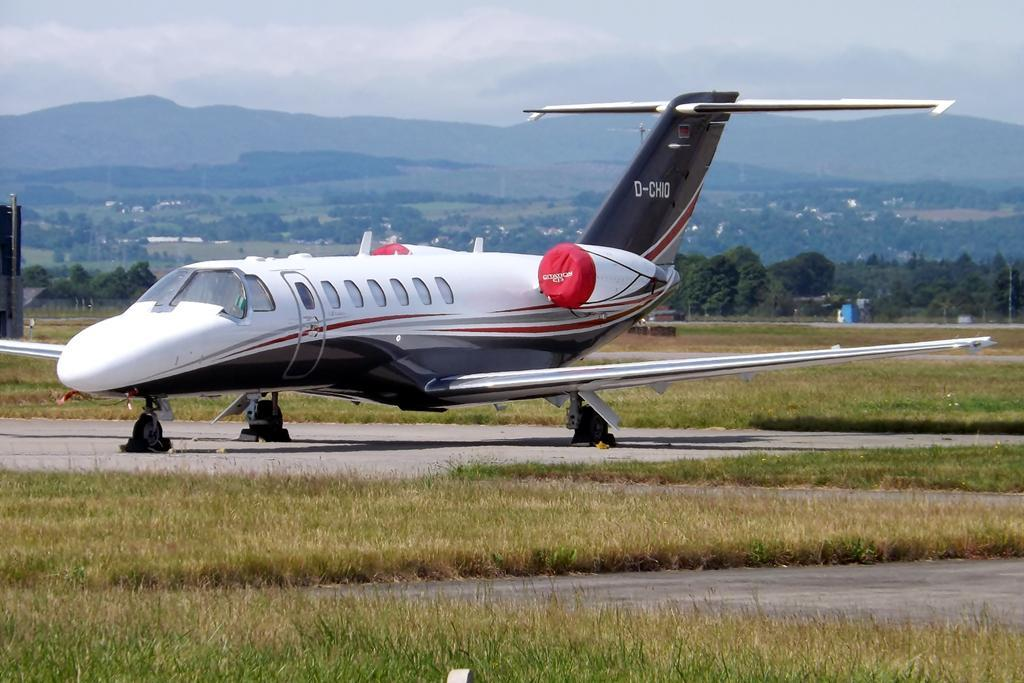What is the main subject of the image? The main subject of the image is an airplane. Where is the airplane located in the image? The airplane is on the land in the image. What type of vegetation is present around the airplane? There is a lot of grass around the airplane. What can be seen in the background of the image? There are mountains in the background of the image. What type of meal is being served on the airplane in the image? There is no meal being served on the airplane in the image; it is stationary on the land with grass around it. Can you see a donkey in the image? There is no donkey present in the image. 